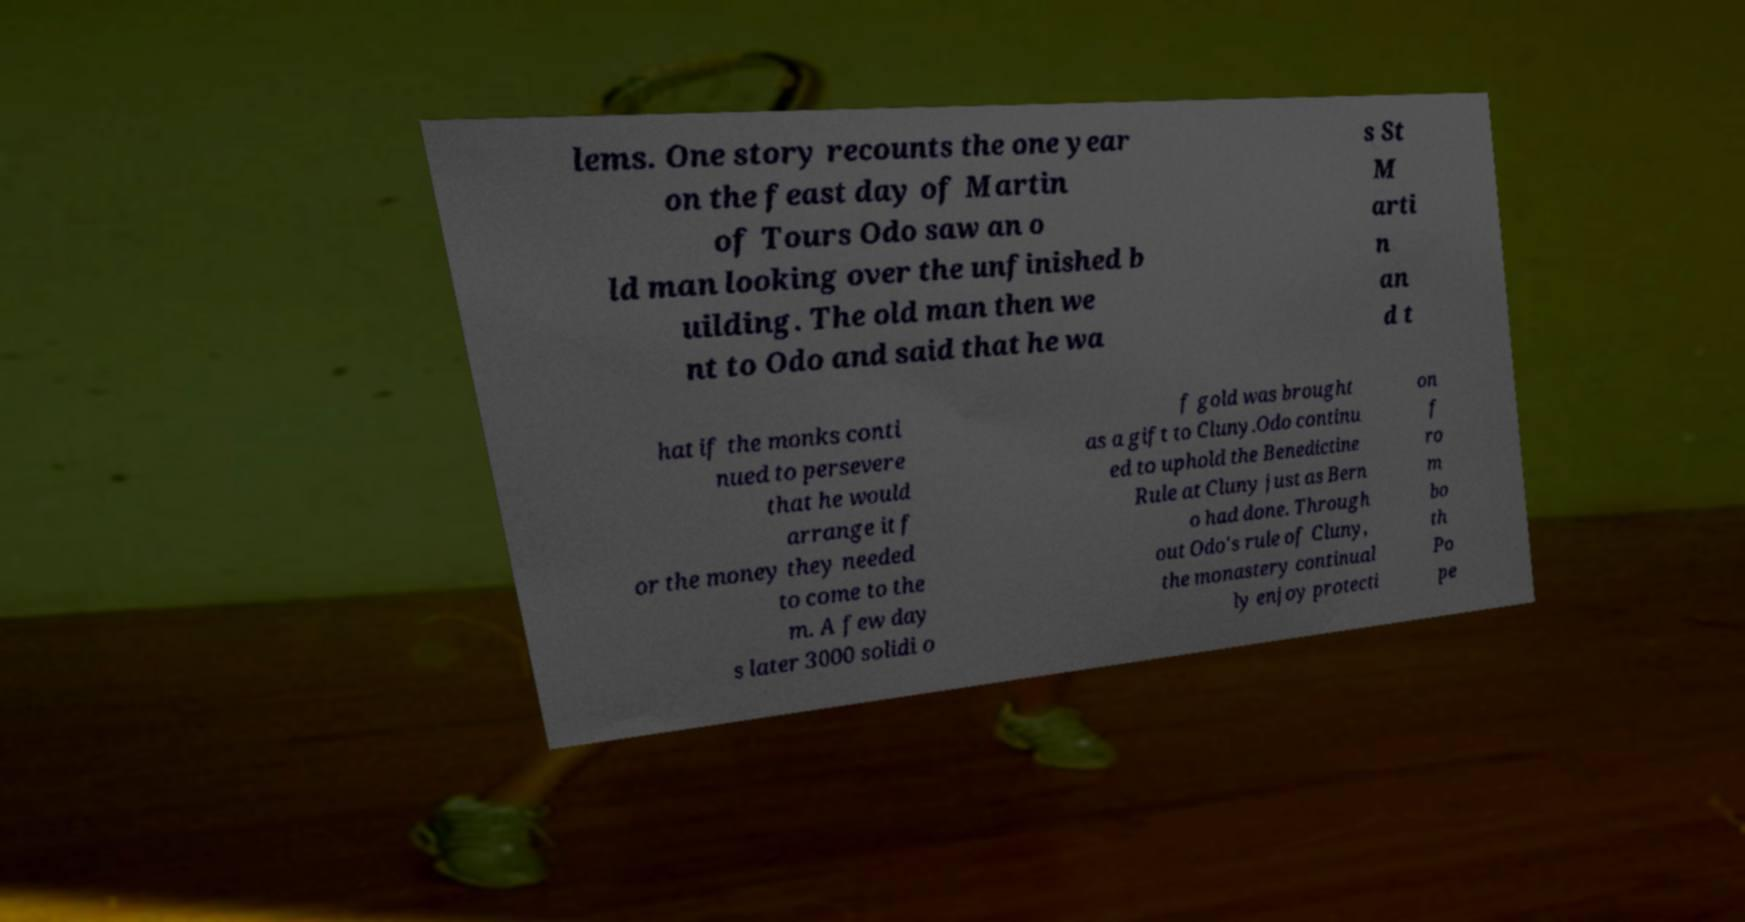Can you accurately transcribe the text from the provided image for me? lems. One story recounts the one year on the feast day of Martin of Tours Odo saw an o ld man looking over the unfinished b uilding. The old man then we nt to Odo and said that he wa s St M arti n an d t hat if the monks conti nued to persevere that he would arrange it f or the money they needed to come to the m. A few day s later 3000 solidi o f gold was brought as a gift to Cluny.Odo continu ed to uphold the Benedictine Rule at Cluny just as Bern o had done. Through out Odo's rule of Cluny, the monastery continual ly enjoy protecti on f ro m bo th Po pe 